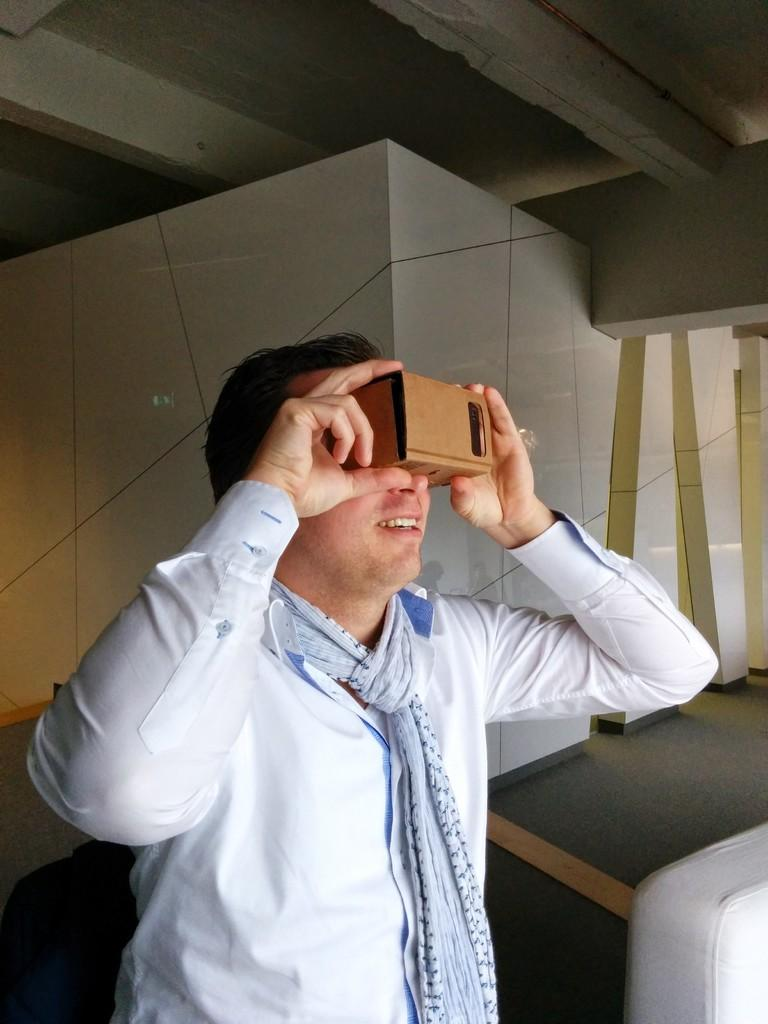What is the person in the image doing? The person is standing in the image. What is the person wearing? The person is wearing a white shirt. What object is the person holding? The person is holding an object that is brown in color. What colors can be seen on the wall in the background? The wall in the background has green and white colors. Can you see any steam coming from the brown object in the image? There is no steam visible in the image. Is the person playing baseball in the image? There is no indication of a baseball or any baseball-related activity in the image. 